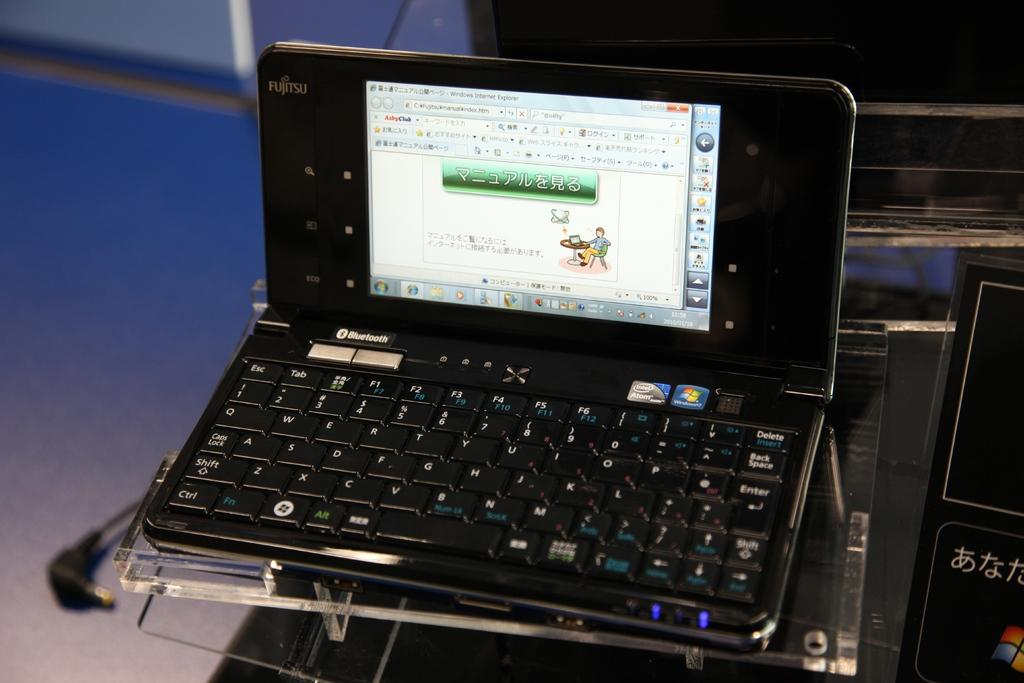<image>
Present a compact description of the photo's key features. a fujitsu laptop/tablet screen open to a japanese website 